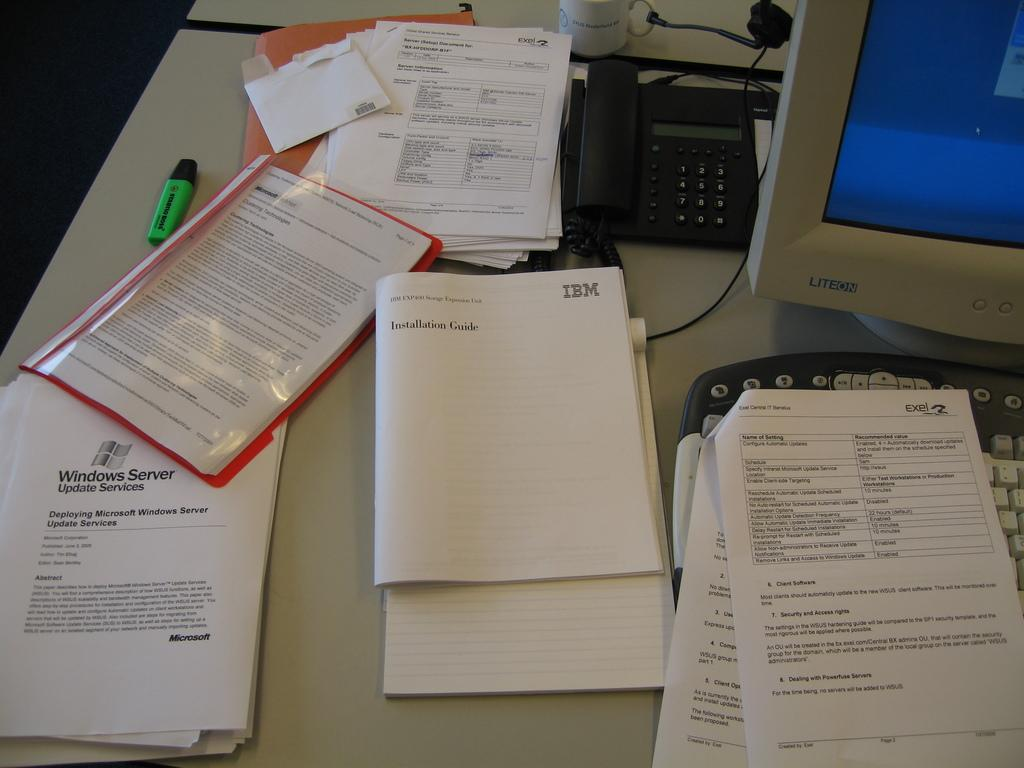<image>
Relay a brief, clear account of the picture shown. a booklet that says 'installation guide' on it 